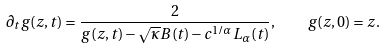<formula> <loc_0><loc_0><loc_500><loc_500>\partial _ { t } g ( z , t ) = \frac { 2 } { g ( z , t ) - \sqrt { \kappa } B ( t ) - c ^ { 1 / \alpha } L _ { \alpha } ( t ) } , \quad g ( z , 0 ) = z .</formula> 